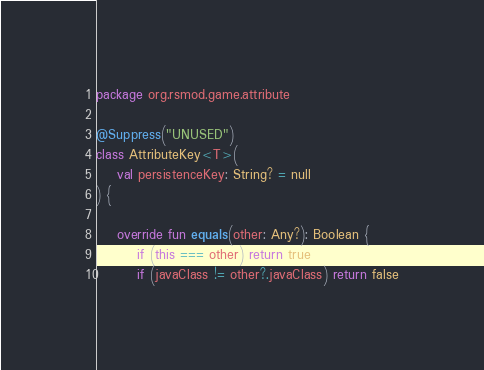<code> <loc_0><loc_0><loc_500><loc_500><_Kotlin_>package org.rsmod.game.attribute

@Suppress("UNUSED")
class AttributeKey<T>(
    val persistenceKey: String? = null
) {

    override fun equals(other: Any?): Boolean {
        if (this === other) return true
        if (javaClass != other?.javaClass) return false
</code> 